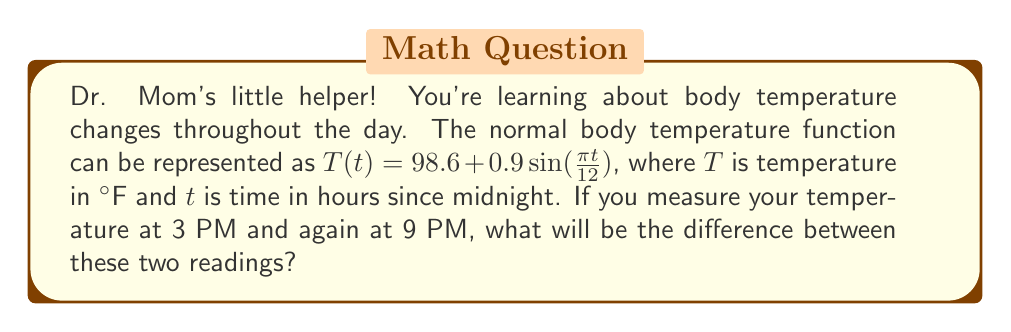Can you solve this math problem? Let's approach this step-by-step:

1) First, we need to convert the given times to hours since midnight:
   3 PM = 15 hours
   9 PM = 21 hours

2) Now, let's calculate the temperature at each time:

   For 3 PM (t = 15):
   $$T(15) = 98.6 + 0.9\sin(\frac{\pi \cdot 15}{12})$$
   $$= 98.6 + 0.9\sin(\frac{5\pi}{4})$$
   $$= 98.6 + 0.9 \cdot (-0.7071)$$
   $$= 98.6 - 0.6364 = 97.9636$$

   For 9 PM (t = 21):
   $$T(21) = 98.6 + 0.9\sin(\frac{\pi \cdot 21}{12})$$
   $$= 98.6 + 0.9\sin(\frac{7\pi}{4})$$
   $$= 98.6 + 0.9 \cdot 0.7071$$
   $$= 98.6 + 0.6364 = 99.2364$$

3) To find the difference, we subtract:
   $$99.2364 - 97.9636 = 1.2728$$

4) Rounding to two decimal places for practical measurement:
   1.27°F
Answer: The difference between the temperature readings at 3 PM and 9 PM will be approximately 1.27°F. 